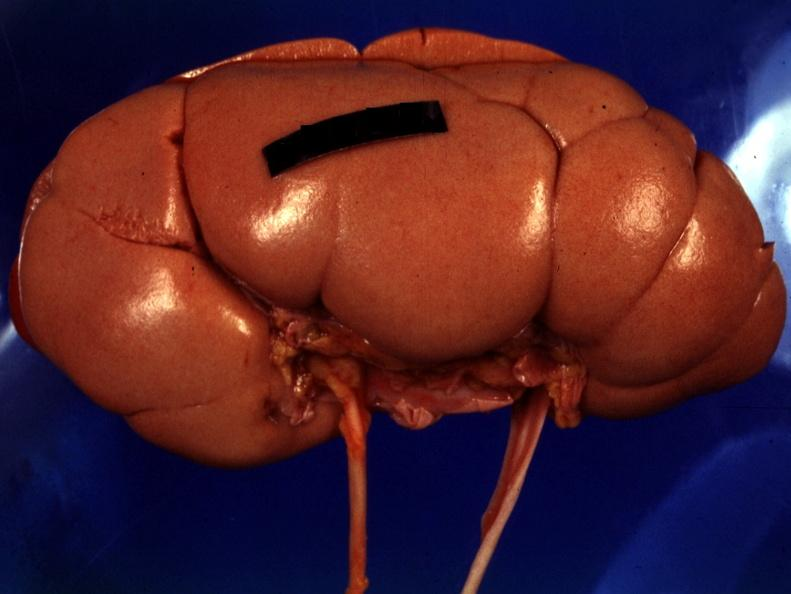what is present?
Answer the question using a single word or phrase. Fetal lobulation 